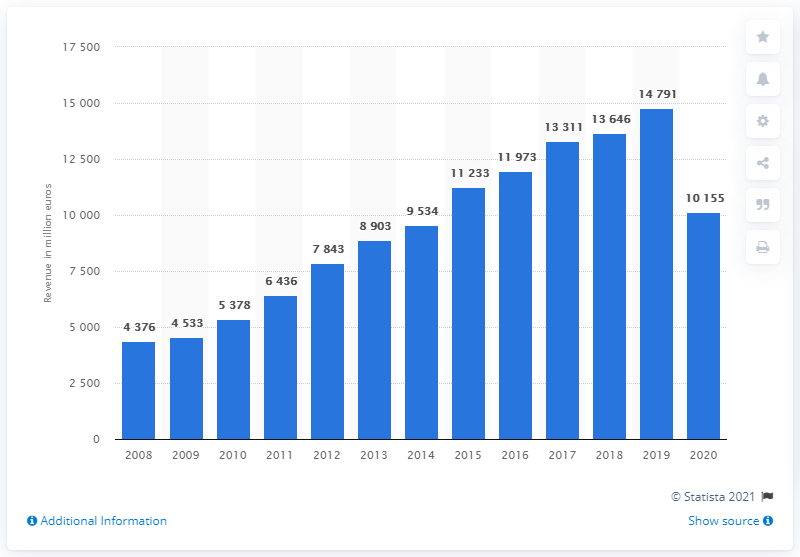Highlight a few significant elements in this photo. LVMH's selective retailing segment generated revenue of 10,155 in 2020. 